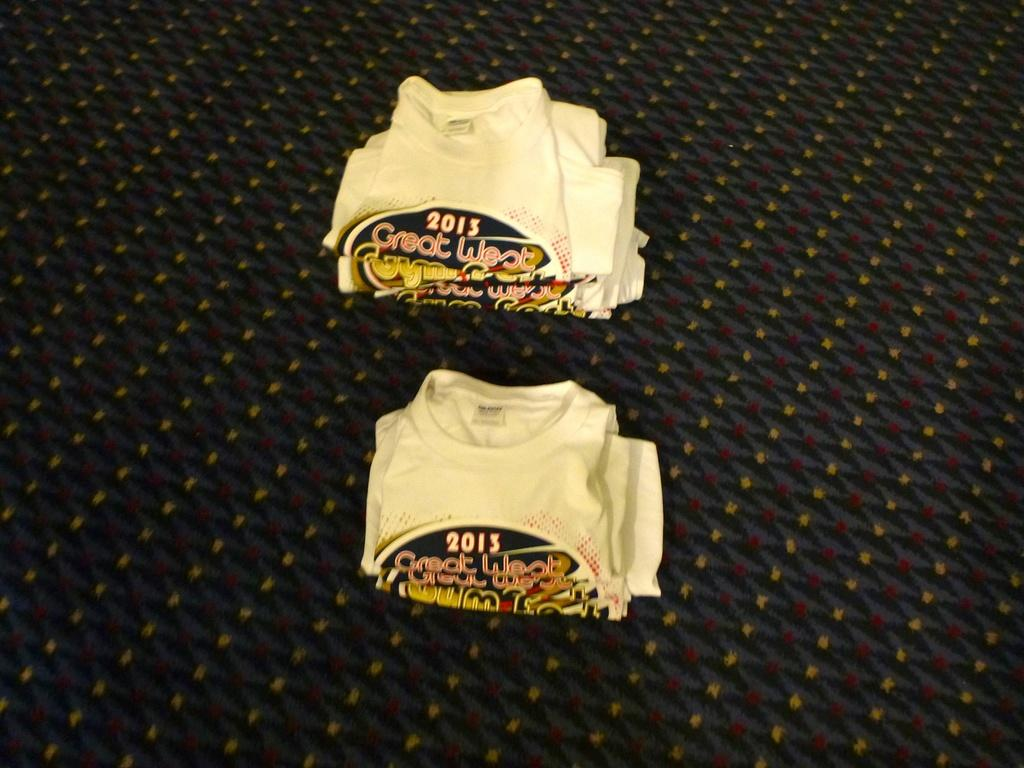<image>
Summarize the visual content of the image. T-shirts with Great West 2013 are folded and laying on a carpet. 